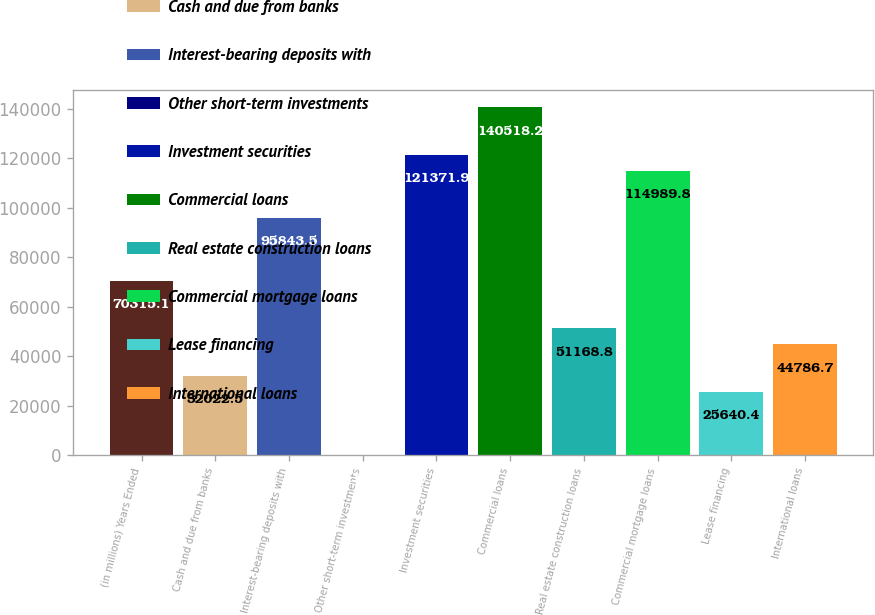Convert chart to OTSL. <chart><loc_0><loc_0><loc_500><loc_500><bar_chart><fcel>(in millions) Years Ended<fcel>Cash and due from banks<fcel>Interest-bearing deposits with<fcel>Other short-term investments<fcel>Investment securities<fcel>Commercial loans<fcel>Real estate construction loans<fcel>Commercial mortgage loans<fcel>Lease financing<fcel>International loans<nl><fcel>70315.1<fcel>32022.5<fcel>95843.5<fcel>112<fcel>121372<fcel>140518<fcel>51168.8<fcel>114990<fcel>25640.4<fcel>44786.7<nl></chart> 